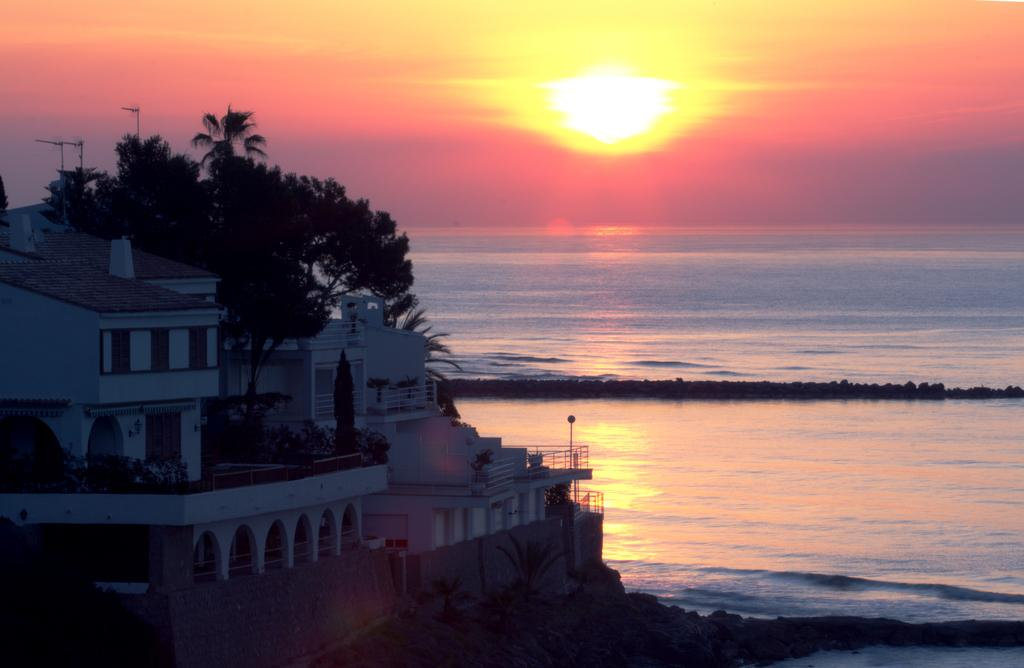What type of structure is shown in the image? There is a beautiful house in the image. What natural feature is visible in front of the house? There is a sea in front of the house. What time of day is depicted in the image? The image depicts a sunrise. Where is the sunrise visible in relation to the sea? The sunrise is visible in front of the sea. What is the value of the house in the image? The value of the house cannot be determined from the image alone. Is the image depicting a winter scene? No, the image depicts a sunrise, which typically occurs during the morning hours, not during winter. 